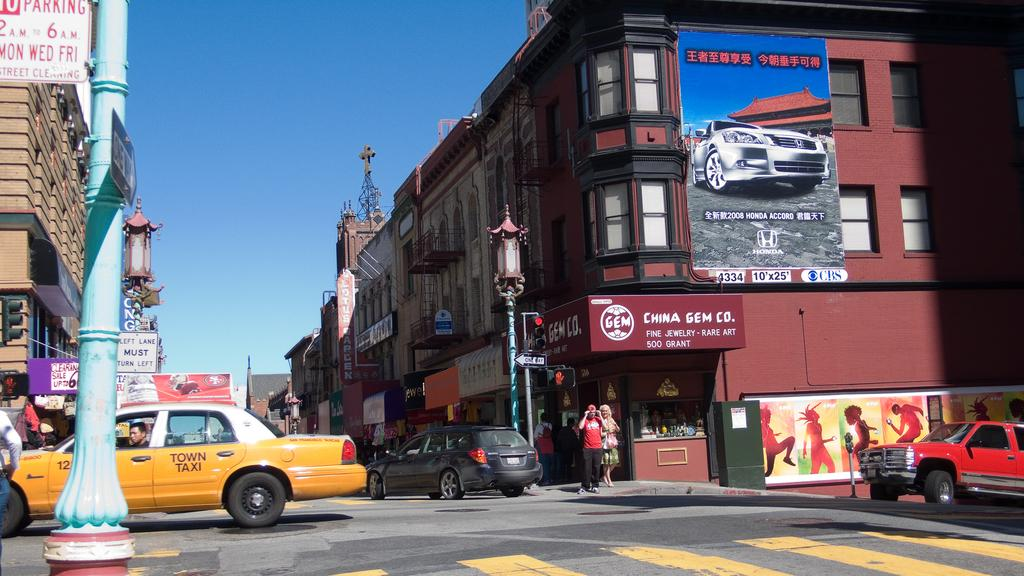<image>
Create a compact narrative representing the image presented. A street scene with a yellow vehicle reading 'town taxi'. 